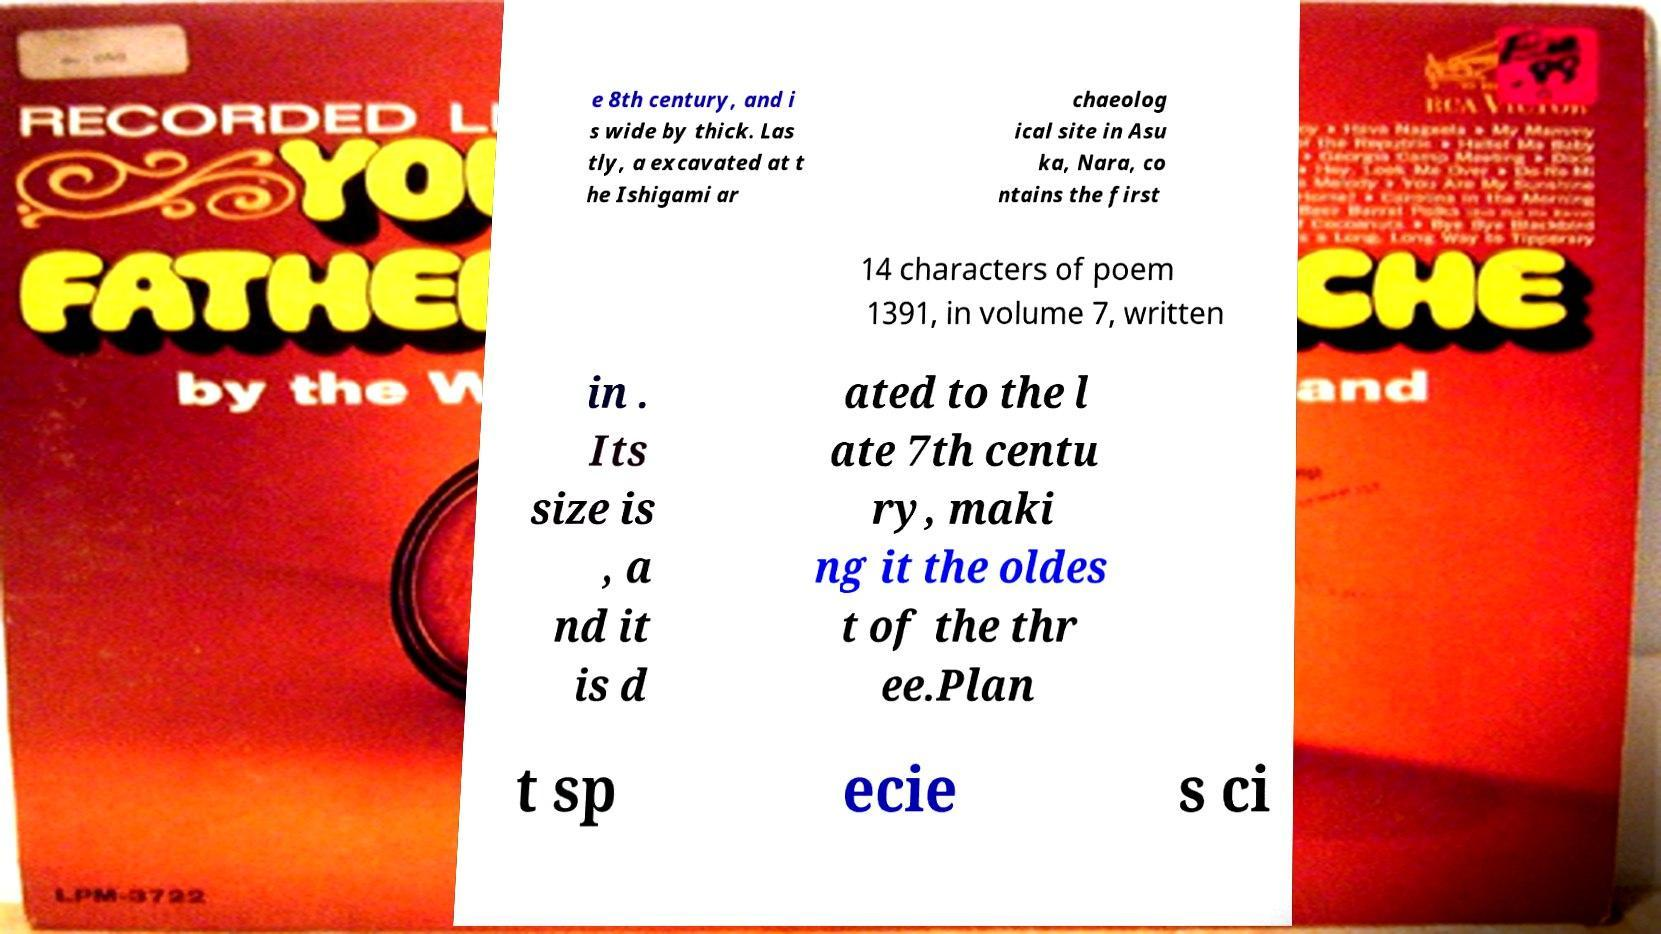Please read and relay the text visible in this image. What does it say? e 8th century, and i s wide by thick. Las tly, a excavated at t he Ishigami ar chaeolog ical site in Asu ka, Nara, co ntains the first 14 characters of poem 1391, in volume 7, written in . Its size is , a nd it is d ated to the l ate 7th centu ry, maki ng it the oldes t of the thr ee.Plan t sp ecie s ci 